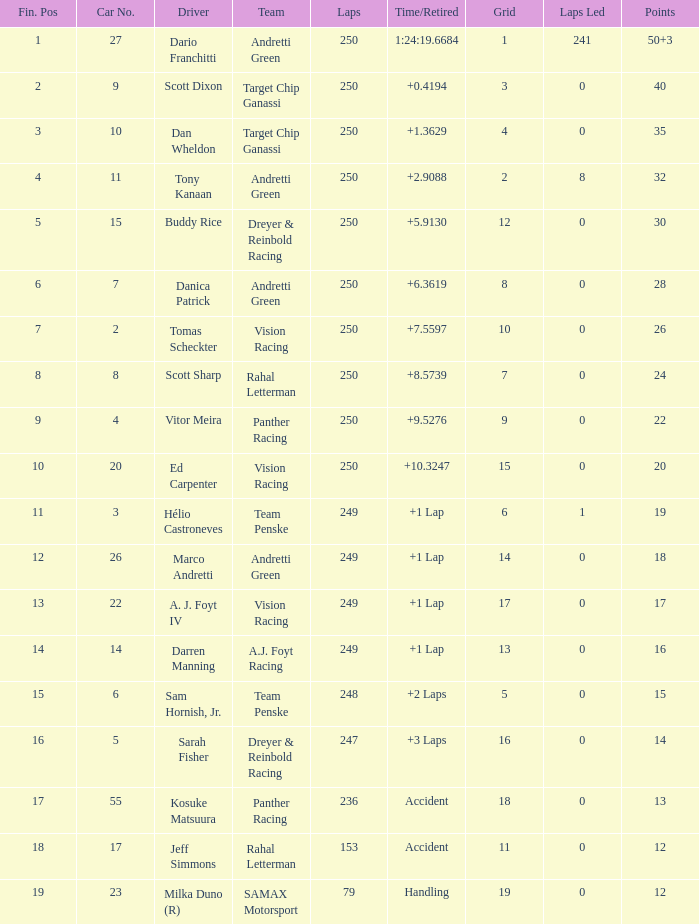Find the least possible grid for 17 points 17.0. 